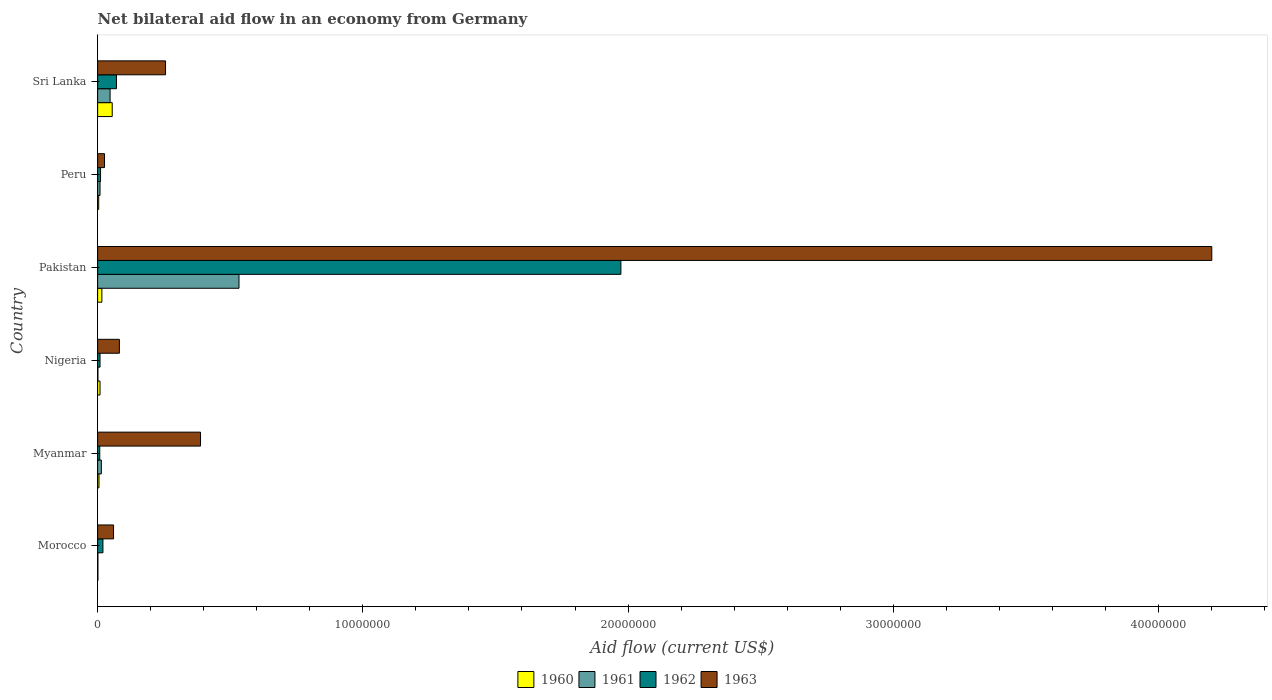How many groups of bars are there?
Your answer should be very brief. 6. How many bars are there on the 1st tick from the top?
Provide a succinct answer. 4. How many bars are there on the 2nd tick from the bottom?
Make the answer very short. 4. What is the label of the 5th group of bars from the top?
Ensure brevity in your answer.  Myanmar. Across all countries, what is the maximum net bilateral aid flow in 1962?
Ensure brevity in your answer.  1.97e+07. Across all countries, what is the minimum net bilateral aid flow in 1961?
Offer a terse response. 10000. In which country was the net bilateral aid flow in 1963 maximum?
Give a very brief answer. Pakistan. In which country was the net bilateral aid flow in 1960 minimum?
Give a very brief answer. Morocco. What is the total net bilateral aid flow in 1961 in the graph?
Provide a short and direct response. 6.05e+06. What is the difference between the net bilateral aid flow in 1960 in Morocco and that in Sri Lanka?
Your answer should be compact. -5.40e+05. What is the difference between the net bilateral aid flow in 1962 in Morocco and the net bilateral aid flow in 1963 in Myanmar?
Make the answer very short. -3.68e+06. What is the average net bilateral aid flow in 1963 per country?
Provide a succinct answer. 8.36e+06. What is the difference between the net bilateral aid flow in 1962 and net bilateral aid flow in 1960 in Pakistan?
Provide a short and direct response. 1.96e+07. What is the ratio of the net bilateral aid flow in 1962 in Pakistan to that in Peru?
Offer a terse response. 179.36. What is the difference between the highest and the second highest net bilateral aid flow in 1963?
Give a very brief answer. 3.81e+07. What is the difference between the highest and the lowest net bilateral aid flow in 1963?
Your answer should be very brief. 4.18e+07. What does the 1st bar from the top in Pakistan represents?
Give a very brief answer. 1963. What does the 4th bar from the bottom in Nigeria represents?
Your answer should be compact. 1963. How many bars are there?
Offer a very short reply. 24. Are all the bars in the graph horizontal?
Your response must be concise. Yes. How many countries are there in the graph?
Make the answer very short. 6. What is the difference between two consecutive major ticks on the X-axis?
Provide a succinct answer. 1.00e+07. Are the values on the major ticks of X-axis written in scientific E-notation?
Provide a short and direct response. No. Does the graph contain any zero values?
Provide a short and direct response. No. Where does the legend appear in the graph?
Make the answer very short. Bottom center. What is the title of the graph?
Offer a terse response. Net bilateral aid flow in an economy from Germany. Does "1982" appear as one of the legend labels in the graph?
Provide a succinct answer. No. What is the label or title of the Y-axis?
Give a very brief answer. Country. What is the Aid flow (current US$) of 1960 in Morocco?
Ensure brevity in your answer.  10000. What is the Aid flow (current US$) of 1961 in Morocco?
Keep it short and to the point. 10000. What is the Aid flow (current US$) of 1962 in Morocco?
Make the answer very short. 2.00e+05. What is the Aid flow (current US$) of 1963 in Morocco?
Your answer should be compact. 6.00e+05. What is the Aid flow (current US$) of 1961 in Myanmar?
Provide a short and direct response. 1.40e+05. What is the Aid flow (current US$) in 1963 in Myanmar?
Your answer should be compact. 3.88e+06. What is the Aid flow (current US$) in 1962 in Nigeria?
Offer a terse response. 9.00e+04. What is the Aid flow (current US$) of 1963 in Nigeria?
Offer a very short reply. 8.20e+05. What is the Aid flow (current US$) of 1960 in Pakistan?
Keep it short and to the point. 1.60e+05. What is the Aid flow (current US$) in 1961 in Pakistan?
Your answer should be very brief. 5.33e+06. What is the Aid flow (current US$) in 1962 in Pakistan?
Keep it short and to the point. 1.97e+07. What is the Aid flow (current US$) of 1963 in Pakistan?
Make the answer very short. 4.20e+07. What is the Aid flow (current US$) in 1960 in Peru?
Keep it short and to the point. 4.00e+04. What is the Aid flow (current US$) in 1962 in Peru?
Provide a succinct answer. 1.10e+05. What is the Aid flow (current US$) in 1960 in Sri Lanka?
Your answer should be compact. 5.50e+05. What is the Aid flow (current US$) in 1962 in Sri Lanka?
Make the answer very short. 7.10e+05. What is the Aid flow (current US$) of 1963 in Sri Lanka?
Give a very brief answer. 2.56e+06. Across all countries, what is the maximum Aid flow (current US$) in 1960?
Keep it short and to the point. 5.50e+05. Across all countries, what is the maximum Aid flow (current US$) in 1961?
Your answer should be compact. 5.33e+06. Across all countries, what is the maximum Aid flow (current US$) of 1962?
Offer a very short reply. 1.97e+07. Across all countries, what is the maximum Aid flow (current US$) of 1963?
Make the answer very short. 4.20e+07. Across all countries, what is the minimum Aid flow (current US$) of 1960?
Provide a succinct answer. 10000. What is the total Aid flow (current US$) in 1960 in the graph?
Your answer should be very brief. 9.00e+05. What is the total Aid flow (current US$) of 1961 in the graph?
Keep it short and to the point. 6.05e+06. What is the total Aid flow (current US$) of 1962 in the graph?
Keep it short and to the point. 2.09e+07. What is the total Aid flow (current US$) in 1963 in the graph?
Make the answer very short. 5.01e+07. What is the difference between the Aid flow (current US$) in 1963 in Morocco and that in Myanmar?
Ensure brevity in your answer.  -3.28e+06. What is the difference between the Aid flow (current US$) in 1960 in Morocco and that in Nigeria?
Offer a very short reply. -8.00e+04. What is the difference between the Aid flow (current US$) in 1961 in Morocco and that in Nigeria?
Make the answer very short. 0. What is the difference between the Aid flow (current US$) in 1962 in Morocco and that in Nigeria?
Give a very brief answer. 1.10e+05. What is the difference between the Aid flow (current US$) of 1963 in Morocco and that in Nigeria?
Ensure brevity in your answer.  -2.20e+05. What is the difference between the Aid flow (current US$) in 1960 in Morocco and that in Pakistan?
Offer a very short reply. -1.50e+05. What is the difference between the Aid flow (current US$) of 1961 in Morocco and that in Pakistan?
Give a very brief answer. -5.32e+06. What is the difference between the Aid flow (current US$) of 1962 in Morocco and that in Pakistan?
Provide a short and direct response. -1.95e+07. What is the difference between the Aid flow (current US$) in 1963 in Morocco and that in Pakistan?
Your response must be concise. -4.14e+07. What is the difference between the Aid flow (current US$) in 1961 in Morocco and that in Peru?
Ensure brevity in your answer.  -8.00e+04. What is the difference between the Aid flow (current US$) in 1962 in Morocco and that in Peru?
Give a very brief answer. 9.00e+04. What is the difference between the Aid flow (current US$) in 1960 in Morocco and that in Sri Lanka?
Ensure brevity in your answer.  -5.40e+05. What is the difference between the Aid flow (current US$) of 1961 in Morocco and that in Sri Lanka?
Offer a very short reply. -4.60e+05. What is the difference between the Aid flow (current US$) of 1962 in Morocco and that in Sri Lanka?
Your answer should be compact. -5.10e+05. What is the difference between the Aid flow (current US$) of 1963 in Morocco and that in Sri Lanka?
Keep it short and to the point. -1.96e+06. What is the difference between the Aid flow (current US$) of 1961 in Myanmar and that in Nigeria?
Make the answer very short. 1.30e+05. What is the difference between the Aid flow (current US$) in 1963 in Myanmar and that in Nigeria?
Make the answer very short. 3.06e+06. What is the difference between the Aid flow (current US$) of 1961 in Myanmar and that in Pakistan?
Provide a short and direct response. -5.19e+06. What is the difference between the Aid flow (current US$) in 1962 in Myanmar and that in Pakistan?
Offer a terse response. -1.96e+07. What is the difference between the Aid flow (current US$) in 1963 in Myanmar and that in Pakistan?
Keep it short and to the point. -3.81e+07. What is the difference between the Aid flow (current US$) in 1961 in Myanmar and that in Peru?
Provide a succinct answer. 5.00e+04. What is the difference between the Aid flow (current US$) in 1962 in Myanmar and that in Peru?
Provide a short and direct response. -3.00e+04. What is the difference between the Aid flow (current US$) of 1963 in Myanmar and that in Peru?
Offer a terse response. 3.62e+06. What is the difference between the Aid flow (current US$) of 1960 in Myanmar and that in Sri Lanka?
Make the answer very short. -5.00e+05. What is the difference between the Aid flow (current US$) in 1961 in Myanmar and that in Sri Lanka?
Your answer should be compact. -3.30e+05. What is the difference between the Aid flow (current US$) of 1962 in Myanmar and that in Sri Lanka?
Your response must be concise. -6.30e+05. What is the difference between the Aid flow (current US$) of 1963 in Myanmar and that in Sri Lanka?
Your answer should be very brief. 1.32e+06. What is the difference between the Aid flow (current US$) in 1960 in Nigeria and that in Pakistan?
Your answer should be very brief. -7.00e+04. What is the difference between the Aid flow (current US$) of 1961 in Nigeria and that in Pakistan?
Offer a terse response. -5.32e+06. What is the difference between the Aid flow (current US$) in 1962 in Nigeria and that in Pakistan?
Your answer should be very brief. -1.96e+07. What is the difference between the Aid flow (current US$) of 1963 in Nigeria and that in Pakistan?
Your answer should be very brief. -4.12e+07. What is the difference between the Aid flow (current US$) of 1960 in Nigeria and that in Peru?
Ensure brevity in your answer.  5.00e+04. What is the difference between the Aid flow (current US$) in 1963 in Nigeria and that in Peru?
Offer a terse response. 5.60e+05. What is the difference between the Aid flow (current US$) in 1960 in Nigeria and that in Sri Lanka?
Provide a short and direct response. -4.60e+05. What is the difference between the Aid flow (current US$) of 1961 in Nigeria and that in Sri Lanka?
Make the answer very short. -4.60e+05. What is the difference between the Aid flow (current US$) in 1962 in Nigeria and that in Sri Lanka?
Keep it short and to the point. -6.20e+05. What is the difference between the Aid flow (current US$) in 1963 in Nigeria and that in Sri Lanka?
Provide a succinct answer. -1.74e+06. What is the difference between the Aid flow (current US$) of 1960 in Pakistan and that in Peru?
Keep it short and to the point. 1.20e+05. What is the difference between the Aid flow (current US$) of 1961 in Pakistan and that in Peru?
Make the answer very short. 5.24e+06. What is the difference between the Aid flow (current US$) in 1962 in Pakistan and that in Peru?
Offer a very short reply. 1.96e+07. What is the difference between the Aid flow (current US$) of 1963 in Pakistan and that in Peru?
Your answer should be compact. 4.18e+07. What is the difference between the Aid flow (current US$) in 1960 in Pakistan and that in Sri Lanka?
Provide a succinct answer. -3.90e+05. What is the difference between the Aid flow (current US$) in 1961 in Pakistan and that in Sri Lanka?
Provide a succinct answer. 4.86e+06. What is the difference between the Aid flow (current US$) in 1962 in Pakistan and that in Sri Lanka?
Offer a very short reply. 1.90e+07. What is the difference between the Aid flow (current US$) in 1963 in Pakistan and that in Sri Lanka?
Provide a short and direct response. 3.94e+07. What is the difference between the Aid flow (current US$) of 1960 in Peru and that in Sri Lanka?
Offer a very short reply. -5.10e+05. What is the difference between the Aid flow (current US$) of 1961 in Peru and that in Sri Lanka?
Offer a very short reply. -3.80e+05. What is the difference between the Aid flow (current US$) of 1962 in Peru and that in Sri Lanka?
Keep it short and to the point. -6.00e+05. What is the difference between the Aid flow (current US$) in 1963 in Peru and that in Sri Lanka?
Offer a very short reply. -2.30e+06. What is the difference between the Aid flow (current US$) of 1960 in Morocco and the Aid flow (current US$) of 1963 in Myanmar?
Make the answer very short. -3.87e+06. What is the difference between the Aid flow (current US$) in 1961 in Morocco and the Aid flow (current US$) in 1962 in Myanmar?
Provide a short and direct response. -7.00e+04. What is the difference between the Aid flow (current US$) in 1961 in Morocco and the Aid flow (current US$) in 1963 in Myanmar?
Provide a succinct answer. -3.87e+06. What is the difference between the Aid flow (current US$) in 1962 in Morocco and the Aid flow (current US$) in 1963 in Myanmar?
Give a very brief answer. -3.68e+06. What is the difference between the Aid flow (current US$) of 1960 in Morocco and the Aid flow (current US$) of 1963 in Nigeria?
Give a very brief answer. -8.10e+05. What is the difference between the Aid flow (current US$) in 1961 in Morocco and the Aid flow (current US$) in 1962 in Nigeria?
Offer a terse response. -8.00e+04. What is the difference between the Aid flow (current US$) of 1961 in Morocco and the Aid flow (current US$) of 1963 in Nigeria?
Offer a terse response. -8.10e+05. What is the difference between the Aid flow (current US$) in 1962 in Morocco and the Aid flow (current US$) in 1963 in Nigeria?
Keep it short and to the point. -6.20e+05. What is the difference between the Aid flow (current US$) in 1960 in Morocco and the Aid flow (current US$) in 1961 in Pakistan?
Make the answer very short. -5.32e+06. What is the difference between the Aid flow (current US$) of 1960 in Morocco and the Aid flow (current US$) of 1962 in Pakistan?
Offer a terse response. -1.97e+07. What is the difference between the Aid flow (current US$) of 1960 in Morocco and the Aid flow (current US$) of 1963 in Pakistan?
Keep it short and to the point. -4.20e+07. What is the difference between the Aid flow (current US$) of 1961 in Morocco and the Aid flow (current US$) of 1962 in Pakistan?
Provide a succinct answer. -1.97e+07. What is the difference between the Aid flow (current US$) of 1961 in Morocco and the Aid flow (current US$) of 1963 in Pakistan?
Provide a succinct answer. -4.20e+07. What is the difference between the Aid flow (current US$) of 1962 in Morocco and the Aid flow (current US$) of 1963 in Pakistan?
Offer a terse response. -4.18e+07. What is the difference between the Aid flow (current US$) in 1960 in Morocco and the Aid flow (current US$) in 1962 in Peru?
Make the answer very short. -1.00e+05. What is the difference between the Aid flow (current US$) in 1960 in Morocco and the Aid flow (current US$) in 1963 in Peru?
Give a very brief answer. -2.50e+05. What is the difference between the Aid flow (current US$) in 1961 in Morocco and the Aid flow (current US$) in 1963 in Peru?
Your answer should be compact. -2.50e+05. What is the difference between the Aid flow (current US$) in 1960 in Morocco and the Aid flow (current US$) in 1961 in Sri Lanka?
Offer a very short reply. -4.60e+05. What is the difference between the Aid flow (current US$) of 1960 in Morocco and the Aid flow (current US$) of 1962 in Sri Lanka?
Provide a succinct answer. -7.00e+05. What is the difference between the Aid flow (current US$) in 1960 in Morocco and the Aid flow (current US$) in 1963 in Sri Lanka?
Provide a succinct answer. -2.55e+06. What is the difference between the Aid flow (current US$) in 1961 in Morocco and the Aid flow (current US$) in 1962 in Sri Lanka?
Make the answer very short. -7.00e+05. What is the difference between the Aid flow (current US$) of 1961 in Morocco and the Aid flow (current US$) of 1963 in Sri Lanka?
Your response must be concise. -2.55e+06. What is the difference between the Aid flow (current US$) in 1962 in Morocco and the Aid flow (current US$) in 1963 in Sri Lanka?
Offer a very short reply. -2.36e+06. What is the difference between the Aid flow (current US$) in 1960 in Myanmar and the Aid flow (current US$) in 1963 in Nigeria?
Your answer should be compact. -7.70e+05. What is the difference between the Aid flow (current US$) of 1961 in Myanmar and the Aid flow (current US$) of 1962 in Nigeria?
Your response must be concise. 5.00e+04. What is the difference between the Aid flow (current US$) of 1961 in Myanmar and the Aid flow (current US$) of 1963 in Nigeria?
Provide a succinct answer. -6.80e+05. What is the difference between the Aid flow (current US$) of 1962 in Myanmar and the Aid flow (current US$) of 1963 in Nigeria?
Your answer should be compact. -7.40e+05. What is the difference between the Aid flow (current US$) of 1960 in Myanmar and the Aid flow (current US$) of 1961 in Pakistan?
Ensure brevity in your answer.  -5.28e+06. What is the difference between the Aid flow (current US$) of 1960 in Myanmar and the Aid flow (current US$) of 1962 in Pakistan?
Make the answer very short. -1.97e+07. What is the difference between the Aid flow (current US$) of 1960 in Myanmar and the Aid flow (current US$) of 1963 in Pakistan?
Provide a short and direct response. -4.20e+07. What is the difference between the Aid flow (current US$) in 1961 in Myanmar and the Aid flow (current US$) in 1962 in Pakistan?
Give a very brief answer. -1.96e+07. What is the difference between the Aid flow (current US$) in 1961 in Myanmar and the Aid flow (current US$) in 1963 in Pakistan?
Your answer should be very brief. -4.19e+07. What is the difference between the Aid flow (current US$) of 1962 in Myanmar and the Aid flow (current US$) of 1963 in Pakistan?
Provide a succinct answer. -4.19e+07. What is the difference between the Aid flow (current US$) of 1960 in Myanmar and the Aid flow (current US$) of 1962 in Peru?
Provide a succinct answer. -6.00e+04. What is the difference between the Aid flow (current US$) in 1961 in Myanmar and the Aid flow (current US$) in 1963 in Peru?
Provide a short and direct response. -1.20e+05. What is the difference between the Aid flow (current US$) of 1962 in Myanmar and the Aid flow (current US$) of 1963 in Peru?
Keep it short and to the point. -1.80e+05. What is the difference between the Aid flow (current US$) of 1960 in Myanmar and the Aid flow (current US$) of 1961 in Sri Lanka?
Provide a succinct answer. -4.20e+05. What is the difference between the Aid flow (current US$) in 1960 in Myanmar and the Aid flow (current US$) in 1962 in Sri Lanka?
Your answer should be very brief. -6.60e+05. What is the difference between the Aid flow (current US$) of 1960 in Myanmar and the Aid flow (current US$) of 1963 in Sri Lanka?
Your answer should be compact. -2.51e+06. What is the difference between the Aid flow (current US$) of 1961 in Myanmar and the Aid flow (current US$) of 1962 in Sri Lanka?
Your answer should be very brief. -5.70e+05. What is the difference between the Aid flow (current US$) of 1961 in Myanmar and the Aid flow (current US$) of 1963 in Sri Lanka?
Provide a succinct answer. -2.42e+06. What is the difference between the Aid flow (current US$) of 1962 in Myanmar and the Aid flow (current US$) of 1963 in Sri Lanka?
Give a very brief answer. -2.48e+06. What is the difference between the Aid flow (current US$) in 1960 in Nigeria and the Aid flow (current US$) in 1961 in Pakistan?
Give a very brief answer. -5.24e+06. What is the difference between the Aid flow (current US$) of 1960 in Nigeria and the Aid flow (current US$) of 1962 in Pakistan?
Offer a terse response. -1.96e+07. What is the difference between the Aid flow (current US$) in 1960 in Nigeria and the Aid flow (current US$) in 1963 in Pakistan?
Your answer should be compact. -4.19e+07. What is the difference between the Aid flow (current US$) of 1961 in Nigeria and the Aid flow (current US$) of 1962 in Pakistan?
Give a very brief answer. -1.97e+07. What is the difference between the Aid flow (current US$) of 1961 in Nigeria and the Aid flow (current US$) of 1963 in Pakistan?
Ensure brevity in your answer.  -4.20e+07. What is the difference between the Aid flow (current US$) of 1962 in Nigeria and the Aid flow (current US$) of 1963 in Pakistan?
Offer a very short reply. -4.19e+07. What is the difference between the Aid flow (current US$) in 1960 in Nigeria and the Aid flow (current US$) in 1961 in Peru?
Offer a terse response. 0. What is the difference between the Aid flow (current US$) in 1961 in Nigeria and the Aid flow (current US$) in 1963 in Peru?
Ensure brevity in your answer.  -2.50e+05. What is the difference between the Aid flow (current US$) of 1960 in Nigeria and the Aid flow (current US$) of 1961 in Sri Lanka?
Provide a short and direct response. -3.80e+05. What is the difference between the Aid flow (current US$) of 1960 in Nigeria and the Aid flow (current US$) of 1962 in Sri Lanka?
Your answer should be compact. -6.20e+05. What is the difference between the Aid flow (current US$) of 1960 in Nigeria and the Aid flow (current US$) of 1963 in Sri Lanka?
Offer a very short reply. -2.47e+06. What is the difference between the Aid flow (current US$) of 1961 in Nigeria and the Aid flow (current US$) of 1962 in Sri Lanka?
Give a very brief answer. -7.00e+05. What is the difference between the Aid flow (current US$) of 1961 in Nigeria and the Aid flow (current US$) of 1963 in Sri Lanka?
Keep it short and to the point. -2.55e+06. What is the difference between the Aid flow (current US$) in 1962 in Nigeria and the Aid flow (current US$) in 1963 in Sri Lanka?
Offer a terse response. -2.47e+06. What is the difference between the Aid flow (current US$) in 1961 in Pakistan and the Aid flow (current US$) in 1962 in Peru?
Provide a succinct answer. 5.22e+06. What is the difference between the Aid flow (current US$) of 1961 in Pakistan and the Aid flow (current US$) of 1963 in Peru?
Offer a very short reply. 5.07e+06. What is the difference between the Aid flow (current US$) in 1962 in Pakistan and the Aid flow (current US$) in 1963 in Peru?
Your response must be concise. 1.95e+07. What is the difference between the Aid flow (current US$) of 1960 in Pakistan and the Aid flow (current US$) of 1961 in Sri Lanka?
Make the answer very short. -3.10e+05. What is the difference between the Aid flow (current US$) of 1960 in Pakistan and the Aid flow (current US$) of 1962 in Sri Lanka?
Your answer should be very brief. -5.50e+05. What is the difference between the Aid flow (current US$) in 1960 in Pakistan and the Aid flow (current US$) in 1963 in Sri Lanka?
Make the answer very short. -2.40e+06. What is the difference between the Aid flow (current US$) of 1961 in Pakistan and the Aid flow (current US$) of 1962 in Sri Lanka?
Your answer should be compact. 4.62e+06. What is the difference between the Aid flow (current US$) in 1961 in Pakistan and the Aid flow (current US$) in 1963 in Sri Lanka?
Offer a very short reply. 2.77e+06. What is the difference between the Aid flow (current US$) of 1962 in Pakistan and the Aid flow (current US$) of 1963 in Sri Lanka?
Your response must be concise. 1.72e+07. What is the difference between the Aid flow (current US$) of 1960 in Peru and the Aid flow (current US$) of 1961 in Sri Lanka?
Provide a short and direct response. -4.30e+05. What is the difference between the Aid flow (current US$) of 1960 in Peru and the Aid flow (current US$) of 1962 in Sri Lanka?
Give a very brief answer. -6.70e+05. What is the difference between the Aid flow (current US$) of 1960 in Peru and the Aid flow (current US$) of 1963 in Sri Lanka?
Your answer should be compact. -2.52e+06. What is the difference between the Aid flow (current US$) of 1961 in Peru and the Aid flow (current US$) of 1962 in Sri Lanka?
Your answer should be compact. -6.20e+05. What is the difference between the Aid flow (current US$) in 1961 in Peru and the Aid flow (current US$) in 1963 in Sri Lanka?
Keep it short and to the point. -2.47e+06. What is the difference between the Aid flow (current US$) in 1962 in Peru and the Aid flow (current US$) in 1963 in Sri Lanka?
Provide a succinct answer. -2.45e+06. What is the average Aid flow (current US$) of 1960 per country?
Give a very brief answer. 1.50e+05. What is the average Aid flow (current US$) in 1961 per country?
Give a very brief answer. 1.01e+06. What is the average Aid flow (current US$) of 1962 per country?
Your answer should be compact. 3.49e+06. What is the average Aid flow (current US$) of 1963 per country?
Keep it short and to the point. 8.36e+06. What is the difference between the Aid flow (current US$) of 1960 and Aid flow (current US$) of 1962 in Morocco?
Keep it short and to the point. -1.90e+05. What is the difference between the Aid flow (current US$) in 1960 and Aid flow (current US$) in 1963 in Morocco?
Offer a terse response. -5.90e+05. What is the difference between the Aid flow (current US$) of 1961 and Aid flow (current US$) of 1962 in Morocco?
Provide a succinct answer. -1.90e+05. What is the difference between the Aid flow (current US$) of 1961 and Aid flow (current US$) of 1963 in Morocco?
Make the answer very short. -5.90e+05. What is the difference between the Aid flow (current US$) of 1962 and Aid flow (current US$) of 1963 in Morocco?
Make the answer very short. -4.00e+05. What is the difference between the Aid flow (current US$) of 1960 and Aid flow (current US$) of 1961 in Myanmar?
Provide a succinct answer. -9.00e+04. What is the difference between the Aid flow (current US$) of 1960 and Aid flow (current US$) of 1963 in Myanmar?
Your answer should be compact. -3.83e+06. What is the difference between the Aid flow (current US$) in 1961 and Aid flow (current US$) in 1963 in Myanmar?
Provide a short and direct response. -3.74e+06. What is the difference between the Aid flow (current US$) in 1962 and Aid flow (current US$) in 1963 in Myanmar?
Make the answer very short. -3.80e+06. What is the difference between the Aid flow (current US$) in 1960 and Aid flow (current US$) in 1963 in Nigeria?
Provide a short and direct response. -7.30e+05. What is the difference between the Aid flow (current US$) in 1961 and Aid flow (current US$) in 1962 in Nigeria?
Provide a short and direct response. -8.00e+04. What is the difference between the Aid flow (current US$) of 1961 and Aid flow (current US$) of 1963 in Nigeria?
Provide a succinct answer. -8.10e+05. What is the difference between the Aid flow (current US$) of 1962 and Aid flow (current US$) of 1963 in Nigeria?
Offer a terse response. -7.30e+05. What is the difference between the Aid flow (current US$) of 1960 and Aid flow (current US$) of 1961 in Pakistan?
Make the answer very short. -5.17e+06. What is the difference between the Aid flow (current US$) of 1960 and Aid flow (current US$) of 1962 in Pakistan?
Make the answer very short. -1.96e+07. What is the difference between the Aid flow (current US$) of 1960 and Aid flow (current US$) of 1963 in Pakistan?
Provide a short and direct response. -4.18e+07. What is the difference between the Aid flow (current US$) in 1961 and Aid flow (current US$) in 1962 in Pakistan?
Provide a succinct answer. -1.44e+07. What is the difference between the Aid flow (current US$) in 1961 and Aid flow (current US$) in 1963 in Pakistan?
Provide a short and direct response. -3.67e+07. What is the difference between the Aid flow (current US$) of 1962 and Aid flow (current US$) of 1963 in Pakistan?
Make the answer very short. -2.23e+07. What is the difference between the Aid flow (current US$) of 1960 and Aid flow (current US$) of 1961 in Peru?
Ensure brevity in your answer.  -5.00e+04. What is the difference between the Aid flow (current US$) in 1960 and Aid flow (current US$) in 1962 in Peru?
Give a very brief answer. -7.00e+04. What is the difference between the Aid flow (current US$) in 1960 and Aid flow (current US$) in 1963 in Peru?
Your response must be concise. -2.20e+05. What is the difference between the Aid flow (current US$) of 1961 and Aid flow (current US$) of 1962 in Peru?
Make the answer very short. -2.00e+04. What is the difference between the Aid flow (current US$) of 1961 and Aid flow (current US$) of 1963 in Peru?
Provide a succinct answer. -1.70e+05. What is the difference between the Aid flow (current US$) of 1962 and Aid flow (current US$) of 1963 in Peru?
Make the answer very short. -1.50e+05. What is the difference between the Aid flow (current US$) in 1960 and Aid flow (current US$) in 1962 in Sri Lanka?
Keep it short and to the point. -1.60e+05. What is the difference between the Aid flow (current US$) in 1960 and Aid flow (current US$) in 1963 in Sri Lanka?
Offer a very short reply. -2.01e+06. What is the difference between the Aid flow (current US$) in 1961 and Aid flow (current US$) in 1963 in Sri Lanka?
Provide a succinct answer. -2.09e+06. What is the difference between the Aid flow (current US$) in 1962 and Aid flow (current US$) in 1963 in Sri Lanka?
Your answer should be very brief. -1.85e+06. What is the ratio of the Aid flow (current US$) of 1961 in Morocco to that in Myanmar?
Provide a succinct answer. 0.07. What is the ratio of the Aid flow (current US$) of 1962 in Morocco to that in Myanmar?
Give a very brief answer. 2.5. What is the ratio of the Aid flow (current US$) in 1963 in Morocco to that in Myanmar?
Provide a short and direct response. 0.15. What is the ratio of the Aid flow (current US$) of 1960 in Morocco to that in Nigeria?
Provide a succinct answer. 0.11. What is the ratio of the Aid flow (current US$) in 1962 in Morocco to that in Nigeria?
Give a very brief answer. 2.22. What is the ratio of the Aid flow (current US$) in 1963 in Morocco to that in Nigeria?
Make the answer very short. 0.73. What is the ratio of the Aid flow (current US$) of 1960 in Morocco to that in Pakistan?
Offer a terse response. 0.06. What is the ratio of the Aid flow (current US$) of 1961 in Morocco to that in Pakistan?
Ensure brevity in your answer.  0. What is the ratio of the Aid flow (current US$) of 1962 in Morocco to that in Pakistan?
Offer a terse response. 0.01. What is the ratio of the Aid flow (current US$) of 1963 in Morocco to that in Pakistan?
Provide a short and direct response. 0.01. What is the ratio of the Aid flow (current US$) in 1960 in Morocco to that in Peru?
Keep it short and to the point. 0.25. What is the ratio of the Aid flow (current US$) of 1962 in Morocco to that in Peru?
Offer a very short reply. 1.82. What is the ratio of the Aid flow (current US$) in 1963 in Morocco to that in Peru?
Keep it short and to the point. 2.31. What is the ratio of the Aid flow (current US$) of 1960 in Morocco to that in Sri Lanka?
Your response must be concise. 0.02. What is the ratio of the Aid flow (current US$) in 1961 in Morocco to that in Sri Lanka?
Your answer should be very brief. 0.02. What is the ratio of the Aid flow (current US$) in 1962 in Morocco to that in Sri Lanka?
Provide a succinct answer. 0.28. What is the ratio of the Aid flow (current US$) of 1963 in Morocco to that in Sri Lanka?
Provide a short and direct response. 0.23. What is the ratio of the Aid flow (current US$) in 1960 in Myanmar to that in Nigeria?
Keep it short and to the point. 0.56. What is the ratio of the Aid flow (current US$) in 1961 in Myanmar to that in Nigeria?
Your answer should be compact. 14. What is the ratio of the Aid flow (current US$) in 1962 in Myanmar to that in Nigeria?
Ensure brevity in your answer.  0.89. What is the ratio of the Aid flow (current US$) of 1963 in Myanmar to that in Nigeria?
Provide a succinct answer. 4.73. What is the ratio of the Aid flow (current US$) of 1960 in Myanmar to that in Pakistan?
Offer a very short reply. 0.31. What is the ratio of the Aid flow (current US$) of 1961 in Myanmar to that in Pakistan?
Ensure brevity in your answer.  0.03. What is the ratio of the Aid flow (current US$) in 1962 in Myanmar to that in Pakistan?
Give a very brief answer. 0. What is the ratio of the Aid flow (current US$) of 1963 in Myanmar to that in Pakistan?
Give a very brief answer. 0.09. What is the ratio of the Aid flow (current US$) in 1960 in Myanmar to that in Peru?
Keep it short and to the point. 1.25. What is the ratio of the Aid flow (current US$) of 1961 in Myanmar to that in Peru?
Ensure brevity in your answer.  1.56. What is the ratio of the Aid flow (current US$) in 1962 in Myanmar to that in Peru?
Give a very brief answer. 0.73. What is the ratio of the Aid flow (current US$) of 1963 in Myanmar to that in Peru?
Your answer should be compact. 14.92. What is the ratio of the Aid flow (current US$) of 1960 in Myanmar to that in Sri Lanka?
Ensure brevity in your answer.  0.09. What is the ratio of the Aid flow (current US$) of 1961 in Myanmar to that in Sri Lanka?
Provide a succinct answer. 0.3. What is the ratio of the Aid flow (current US$) in 1962 in Myanmar to that in Sri Lanka?
Ensure brevity in your answer.  0.11. What is the ratio of the Aid flow (current US$) of 1963 in Myanmar to that in Sri Lanka?
Your response must be concise. 1.52. What is the ratio of the Aid flow (current US$) of 1960 in Nigeria to that in Pakistan?
Your answer should be very brief. 0.56. What is the ratio of the Aid flow (current US$) of 1961 in Nigeria to that in Pakistan?
Offer a very short reply. 0. What is the ratio of the Aid flow (current US$) in 1962 in Nigeria to that in Pakistan?
Your answer should be compact. 0. What is the ratio of the Aid flow (current US$) in 1963 in Nigeria to that in Pakistan?
Ensure brevity in your answer.  0.02. What is the ratio of the Aid flow (current US$) of 1960 in Nigeria to that in Peru?
Your answer should be compact. 2.25. What is the ratio of the Aid flow (current US$) of 1962 in Nigeria to that in Peru?
Your response must be concise. 0.82. What is the ratio of the Aid flow (current US$) in 1963 in Nigeria to that in Peru?
Provide a short and direct response. 3.15. What is the ratio of the Aid flow (current US$) of 1960 in Nigeria to that in Sri Lanka?
Provide a succinct answer. 0.16. What is the ratio of the Aid flow (current US$) in 1961 in Nigeria to that in Sri Lanka?
Make the answer very short. 0.02. What is the ratio of the Aid flow (current US$) of 1962 in Nigeria to that in Sri Lanka?
Ensure brevity in your answer.  0.13. What is the ratio of the Aid flow (current US$) in 1963 in Nigeria to that in Sri Lanka?
Give a very brief answer. 0.32. What is the ratio of the Aid flow (current US$) in 1960 in Pakistan to that in Peru?
Ensure brevity in your answer.  4. What is the ratio of the Aid flow (current US$) in 1961 in Pakistan to that in Peru?
Provide a short and direct response. 59.22. What is the ratio of the Aid flow (current US$) in 1962 in Pakistan to that in Peru?
Your answer should be compact. 179.36. What is the ratio of the Aid flow (current US$) of 1963 in Pakistan to that in Peru?
Your answer should be very brief. 161.58. What is the ratio of the Aid flow (current US$) of 1960 in Pakistan to that in Sri Lanka?
Make the answer very short. 0.29. What is the ratio of the Aid flow (current US$) in 1961 in Pakistan to that in Sri Lanka?
Ensure brevity in your answer.  11.34. What is the ratio of the Aid flow (current US$) in 1962 in Pakistan to that in Sri Lanka?
Keep it short and to the point. 27.79. What is the ratio of the Aid flow (current US$) in 1963 in Pakistan to that in Sri Lanka?
Give a very brief answer. 16.41. What is the ratio of the Aid flow (current US$) in 1960 in Peru to that in Sri Lanka?
Your answer should be compact. 0.07. What is the ratio of the Aid flow (current US$) of 1961 in Peru to that in Sri Lanka?
Offer a very short reply. 0.19. What is the ratio of the Aid flow (current US$) in 1962 in Peru to that in Sri Lanka?
Keep it short and to the point. 0.15. What is the ratio of the Aid flow (current US$) in 1963 in Peru to that in Sri Lanka?
Offer a terse response. 0.1. What is the difference between the highest and the second highest Aid flow (current US$) of 1960?
Make the answer very short. 3.90e+05. What is the difference between the highest and the second highest Aid flow (current US$) of 1961?
Your answer should be very brief. 4.86e+06. What is the difference between the highest and the second highest Aid flow (current US$) in 1962?
Keep it short and to the point. 1.90e+07. What is the difference between the highest and the second highest Aid flow (current US$) of 1963?
Keep it short and to the point. 3.81e+07. What is the difference between the highest and the lowest Aid flow (current US$) of 1960?
Provide a short and direct response. 5.40e+05. What is the difference between the highest and the lowest Aid flow (current US$) of 1961?
Keep it short and to the point. 5.32e+06. What is the difference between the highest and the lowest Aid flow (current US$) in 1962?
Provide a succinct answer. 1.96e+07. What is the difference between the highest and the lowest Aid flow (current US$) in 1963?
Offer a very short reply. 4.18e+07. 